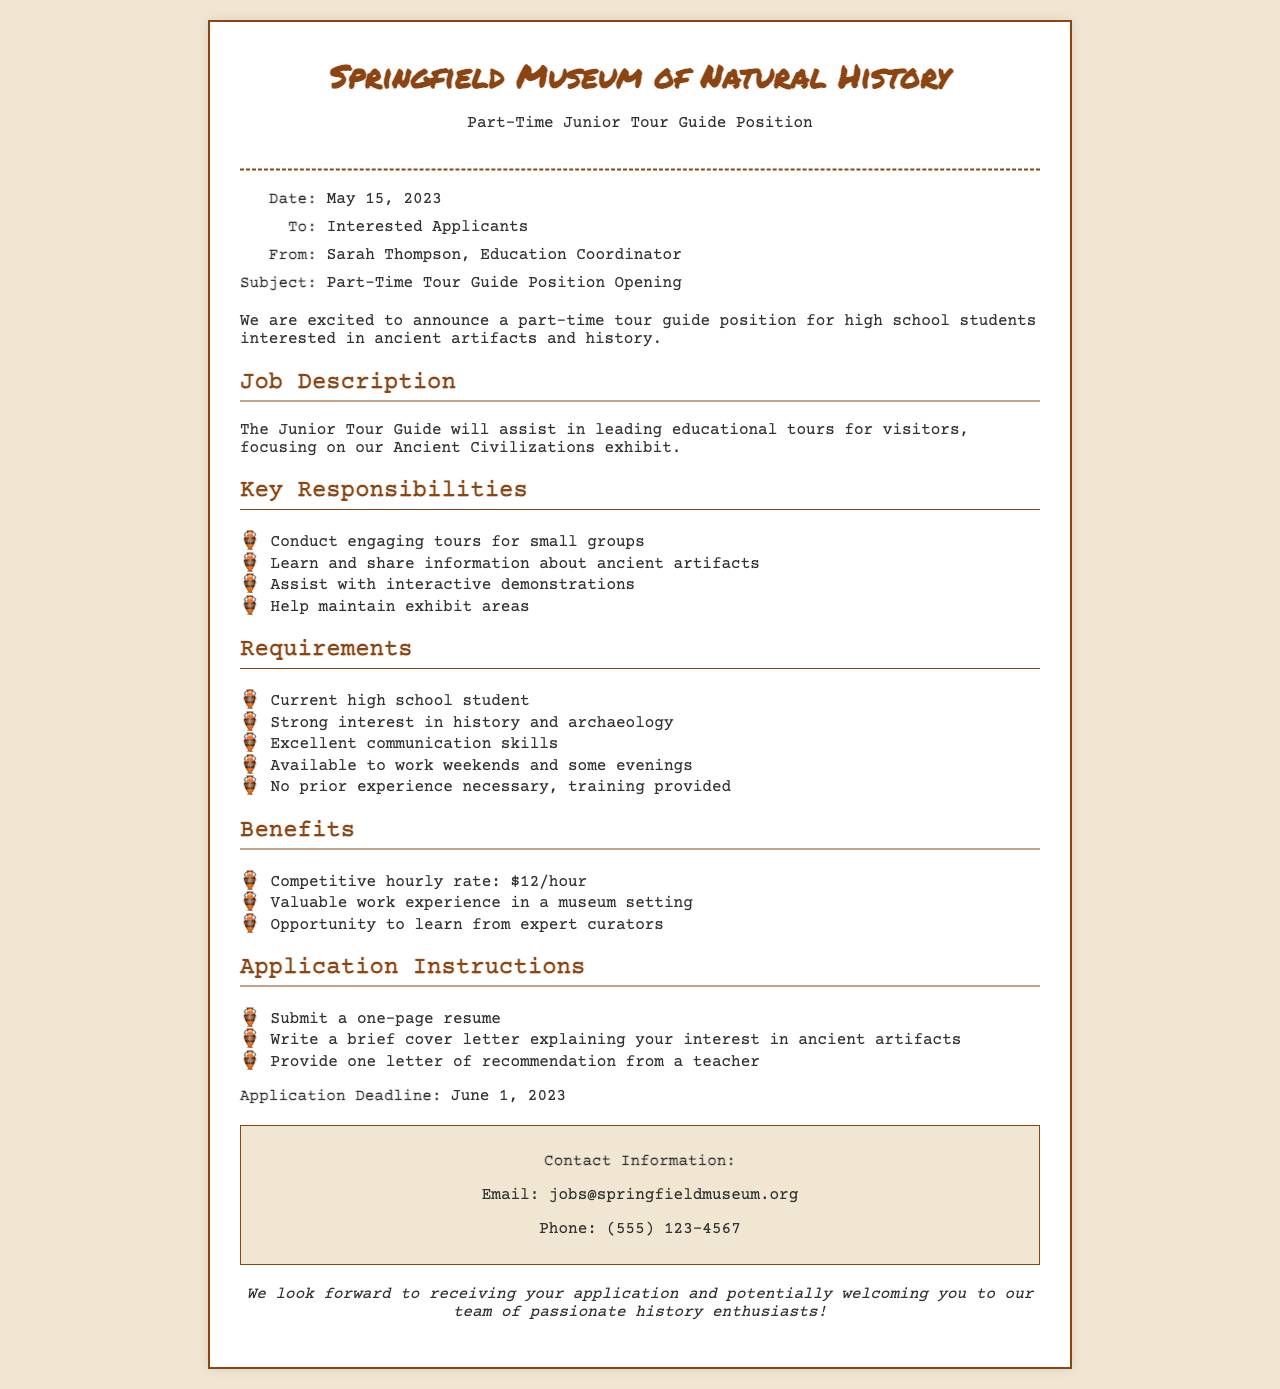What is the name of the museum? The name of the museum is provided in the document's header.
Answer: Springfield Museum of Natural History What is the job title being offered? The job title can be found in the header and subject line of the fax.
Answer: Part-Time Junior Tour Guide Position Who is the sender of the fax? The sender's name is included in the "From" section of the fax details.
Answer: Sarah Thompson What is the competitive hourly rate? The competitive hourly rate is mentioned in the benefits section of the fax.
Answer: $12/hour When is the application deadline? The application deadline is stated explicitly in the document.
Answer: June 1, 2023 What is a requirement for the job? The requirements are listed in a bullet point format, highlighting necessary qualifications.
Answer: Current high school student What should applicants submit with their application? The application instructions outline what is required to apply for the position.
Answer: One-page resume How many responsibilities are listed in the job description? The responsibilities are detailed in a bullet point list, indicating how many there are.
Answer: Four What kind of experience is necessary for this position? The requirements specify the level of experience needed for applicants.
Answer: No prior experience necessary What type of skills are emphasized for this job? The requirements mention specific skills that are crucial for applicants.
Answer: Excellent communication skills 